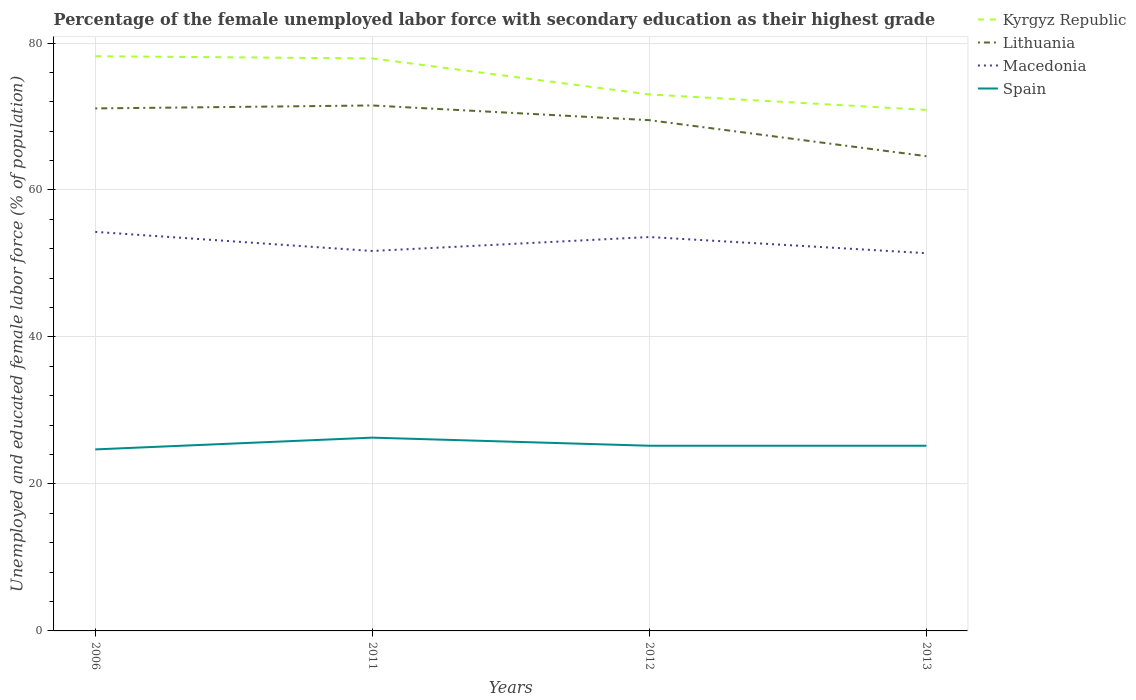Does the line corresponding to Kyrgyz Republic intersect with the line corresponding to Lithuania?
Provide a short and direct response. No. Across all years, what is the maximum percentage of the unemployed female labor force with secondary education in Kyrgyz Republic?
Provide a short and direct response. 70.9. What is the total percentage of the unemployed female labor force with secondary education in Kyrgyz Republic in the graph?
Your answer should be very brief. 4.9. What is the difference between the highest and the second highest percentage of the unemployed female labor force with secondary education in Spain?
Provide a succinct answer. 1.6. Does the graph contain grids?
Your response must be concise. Yes. How many legend labels are there?
Your answer should be compact. 4. How are the legend labels stacked?
Offer a terse response. Vertical. What is the title of the graph?
Ensure brevity in your answer.  Percentage of the female unemployed labor force with secondary education as their highest grade. Does "Zimbabwe" appear as one of the legend labels in the graph?
Your answer should be compact. No. What is the label or title of the Y-axis?
Ensure brevity in your answer.  Unemployed and educated female labor force (% of population). What is the Unemployed and educated female labor force (% of population) in Kyrgyz Republic in 2006?
Make the answer very short. 78.2. What is the Unemployed and educated female labor force (% of population) of Lithuania in 2006?
Your answer should be compact. 71.1. What is the Unemployed and educated female labor force (% of population) of Macedonia in 2006?
Your response must be concise. 54.3. What is the Unemployed and educated female labor force (% of population) of Spain in 2006?
Ensure brevity in your answer.  24.7. What is the Unemployed and educated female labor force (% of population) of Kyrgyz Republic in 2011?
Offer a very short reply. 77.9. What is the Unemployed and educated female labor force (% of population) in Lithuania in 2011?
Offer a terse response. 71.5. What is the Unemployed and educated female labor force (% of population) in Macedonia in 2011?
Keep it short and to the point. 51.7. What is the Unemployed and educated female labor force (% of population) in Spain in 2011?
Make the answer very short. 26.3. What is the Unemployed and educated female labor force (% of population) in Lithuania in 2012?
Ensure brevity in your answer.  69.5. What is the Unemployed and educated female labor force (% of population) of Macedonia in 2012?
Provide a succinct answer. 53.6. What is the Unemployed and educated female labor force (% of population) in Spain in 2012?
Ensure brevity in your answer.  25.2. What is the Unemployed and educated female labor force (% of population) in Kyrgyz Republic in 2013?
Give a very brief answer. 70.9. What is the Unemployed and educated female labor force (% of population) of Lithuania in 2013?
Give a very brief answer. 64.6. What is the Unemployed and educated female labor force (% of population) of Macedonia in 2013?
Ensure brevity in your answer.  51.4. What is the Unemployed and educated female labor force (% of population) of Spain in 2013?
Your answer should be very brief. 25.2. Across all years, what is the maximum Unemployed and educated female labor force (% of population) in Kyrgyz Republic?
Your answer should be compact. 78.2. Across all years, what is the maximum Unemployed and educated female labor force (% of population) in Lithuania?
Give a very brief answer. 71.5. Across all years, what is the maximum Unemployed and educated female labor force (% of population) in Macedonia?
Your response must be concise. 54.3. Across all years, what is the maximum Unemployed and educated female labor force (% of population) of Spain?
Provide a succinct answer. 26.3. Across all years, what is the minimum Unemployed and educated female labor force (% of population) of Kyrgyz Republic?
Ensure brevity in your answer.  70.9. Across all years, what is the minimum Unemployed and educated female labor force (% of population) in Lithuania?
Ensure brevity in your answer.  64.6. Across all years, what is the minimum Unemployed and educated female labor force (% of population) in Macedonia?
Offer a terse response. 51.4. Across all years, what is the minimum Unemployed and educated female labor force (% of population) in Spain?
Your response must be concise. 24.7. What is the total Unemployed and educated female labor force (% of population) of Kyrgyz Republic in the graph?
Keep it short and to the point. 300. What is the total Unemployed and educated female labor force (% of population) of Lithuania in the graph?
Offer a terse response. 276.7. What is the total Unemployed and educated female labor force (% of population) in Macedonia in the graph?
Offer a terse response. 211. What is the total Unemployed and educated female labor force (% of population) of Spain in the graph?
Offer a very short reply. 101.4. What is the difference between the Unemployed and educated female labor force (% of population) in Kyrgyz Republic in 2006 and that in 2011?
Your answer should be compact. 0.3. What is the difference between the Unemployed and educated female labor force (% of population) in Lithuania in 2006 and that in 2011?
Make the answer very short. -0.4. What is the difference between the Unemployed and educated female labor force (% of population) of Macedonia in 2006 and that in 2011?
Give a very brief answer. 2.6. What is the difference between the Unemployed and educated female labor force (% of population) of Spain in 2006 and that in 2011?
Offer a terse response. -1.6. What is the difference between the Unemployed and educated female labor force (% of population) of Macedonia in 2006 and that in 2012?
Your answer should be compact. 0.7. What is the difference between the Unemployed and educated female labor force (% of population) of Kyrgyz Republic in 2006 and that in 2013?
Your response must be concise. 7.3. What is the difference between the Unemployed and educated female labor force (% of population) of Lithuania in 2006 and that in 2013?
Offer a terse response. 6.5. What is the difference between the Unemployed and educated female labor force (% of population) of Macedonia in 2006 and that in 2013?
Give a very brief answer. 2.9. What is the difference between the Unemployed and educated female labor force (% of population) of Macedonia in 2011 and that in 2012?
Your response must be concise. -1.9. What is the difference between the Unemployed and educated female labor force (% of population) in Spain in 2011 and that in 2012?
Make the answer very short. 1.1. What is the difference between the Unemployed and educated female labor force (% of population) in Lithuania in 2011 and that in 2013?
Keep it short and to the point. 6.9. What is the difference between the Unemployed and educated female labor force (% of population) of Lithuania in 2012 and that in 2013?
Make the answer very short. 4.9. What is the difference between the Unemployed and educated female labor force (% of population) in Macedonia in 2012 and that in 2013?
Provide a succinct answer. 2.2. What is the difference between the Unemployed and educated female labor force (% of population) in Spain in 2012 and that in 2013?
Provide a succinct answer. 0. What is the difference between the Unemployed and educated female labor force (% of population) of Kyrgyz Republic in 2006 and the Unemployed and educated female labor force (% of population) of Macedonia in 2011?
Your response must be concise. 26.5. What is the difference between the Unemployed and educated female labor force (% of population) of Kyrgyz Republic in 2006 and the Unemployed and educated female labor force (% of population) of Spain in 2011?
Keep it short and to the point. 51.9. What is the difference between the Unemployed and educated female labor force (% of population) of Lithuania in 2006 and the Unemployed and educated female labor force (% of population) of Spain in 2011?
Keep it short and to the point. 44.8. What is the difference between the Unemployed and educated female labor force (% of population) of Macedonia in 2006 and the Unemployed and educated female labor force (% of population) of Spain in 2011?
Your response must be concise. 28. What is the difference between the Unemployed and educated female labor force (% of population) in Kyrgyz Republic in 2006 and the Unemployed and educated female labor force (% of population) in Lithuania in 2012?
Your answer should be very brief. 8.7. What is the difference between the Unemployed and educated female labor force (% of population) of Kyrgyz Republic in 2006 and the Unemployed and educated female labor force (% of population) of Macedonia in 2012?
Offer a very short reply. 24.6. What is the difference between the Unemployed and educated female labor force (% of population) in Lithuania in 2006 and the Unemployed and educated female labor force (% of population) in Macedonia in 2012?
Ensure brevity in your answer.  17.5. What is the difference between the Unemployed and educated female labor force (% of population) in Lithuania in 2006 and the Unemployed and educated female labor force (% of population) in Spain in 2012?
Your response must be concise. 45.9. What is the difference between the Unemployed and educated female labor force (% of population) in Macedonia in 2006 and the Unemployed and educated female labor force (% of population) in Spain in 2012?
Offer a terse response. 29.1. What is the difference between the Unemployed and educated female labor force (% of population) of Kyrgyz Republic in 2006 and the Unemployed and educated female labor force (% of population) of Lithuania in 2013?
Your answer should be very brief. 13.6. What is the difference between the Unemployed and educated female labor force (% of population) of Kyrgyz Republic in 2006 and the Unemployed and educated female labor force (% of population) of Macedonia in 2013?
Provide a succinct answer. 26.8. What is the difference between the Unemployed and educated female labor force (% of population) of Kyrgyz Republic in 2006 and the Unemployed and educated female labor force (% of population) of Spain in 2013?
Your answer should be very brief. 53. What is the difference between the Unemployed and educated female labor force (% of population) in Lithuania in 2006 and the Unemployed and educated female labor force (% of population) in Macedonia in 2013?
Provide a short and direct response. 19.7. What is the difference between the Unemployed and educated female labor force (% of population) of Lithuania in 2006 and the Unemployed and educated female labor force (% of population) of Spain in 2013?
Ensure brevity in your answer.  45.9. What is the difference between the Unemployed and educated female labor force (% of population) of Macedonia in 2006 and the Unemployed and educated female labor force (% of population) of Spain in 2013?
Keep it short and to the point. 29.1. What is the difference between the Unemployed and educated female labor force (% of population) of Kyrgyz Republic in 2011 and the Unemployed and educated female labor force (% of population) of Macedonia in 2012?
Your answer should be compact. 24.3. What is the difference between the Unemployed and educated female labor force (% of population) in Kyrgyz Republic in 2011 and the Unemployed and educated female labor force (% of population) in Spain in 2012?
Your answer should be compact. 52.7. What is the difference between the Unemployed and educated female labor force (% of population) in Lithuania in 2011 and the Unemployed and educated female labor force (% of population) in Macedonia in 2012?
Your response must be concise. 17.9. What is the difference between the Unemployed and educated female labor force (% of population) of Lithuania in 2011 and the Unemployed and educated female labor force (% of population) of Spain in 2012?
Make the answer very short. 46.3. What is the difference between the Unemployed and educated female labor force (% of population) in Macedonia in 2011 and the Unemployed and educated female labor force (% of population) in Spain in 2012?
Offer a very short reply. 26.5. What is the difference between the Unemployed and educated female labor force (% of population) of Kyrgyz Republic in 2011 and the Unemployed and educated female labor force (% of population) of Spain in 2013?
Provide a succinct answer. 52.7. What is the difference between the Unemployed and educated female labor force (% of population) in Lithuania in 2011 and the Unemployed and educated female labor force (% of population) in Macedonia in 2013?
Make the answer very short. 20.1. What is the difference between the Unemployed and educated female labor force (% of population) of Lithuania in 2011 and the Unemployed and educated female labor force (% of population) of Spain in 2013?
Provide a succinct answer. 46.3. What is the difference between the Unemployed and educated female labor force (% of population) of Macedonia in 2011 and the Unemployed and educated female labor force (% of population) of Spain in 2013?
Offer a very short reply. 26.5. What is the difference between the Unemployed and educated female labor force (% of population) in Kyrgyz Republic in 2012 and the Unemployed and educated female labor force (% of population) in Macedonia in 2013?
Offer a terse response. 21.6. What is the difference between the Unemployed and educated female labor force (% of population) in Kyrgyz Republic in 2012 and the Unemployed and educated female labor force (% of population) in Spain in 2013?
Ensure brevity in your answer.  47.8. What is the difference between the Unemployed and educated female labor force (% of population) of Lithuania in 2012 and the Unemployed and educated female labor force (% of population) of Macedonia in 2013?
Offer a very short reply. 18.1. What is the difference between the Unemployed and educated female labor force (% of population) of Lithuania in 2012 and the Unemployed and educated female labor force (% of population) of Spain in 2013?
Provide a short and direct response. 44.3. What is the difference between the Unemployed and educated female labor force (% of population) in Macedonia in 2012 and the Unemployed and educated female labor force (% of population) in Spain in 2013?
Ensure brevity in your answer.  28.4. What is the average Unemployed and educated female labor force (% of population) of Kyrgyz Republic per year?
Ensure brevity in your answer.  75. What is the average Unemployed and educated female labor force (% of population) of Lithuania per year?
Your answer should be compact. 69.17. What is the average Unemployed and educated female labor force (% of population) of Macedonia per year?
Give a very brief answer. 52.75. What is the average Unemployed and educated female labor force (% of population) in Spain per year?
Provide a short and direct response. 25.35. In the year 2006, what is the difference between the Unemployed and educated female labor force (% of population) of Kyrgyz Republic and Unemployed and educated female labor force (% of population) of Lithuania?
Keep it short and to the point. 7.1. In the year 2006, what is the difference between the Unemployed and educated female labor force (% of population) of Kyrgyz Republic and Unemployed and educated female labor force (% of population) of Macedonia?
Your answer should be compact. 23.9. In the year 2006, what is the difference between the Unemployed and educated female labor force (% of population) of Kyrgyz Republic and Unemployed and educated female labor force (% of population) of Spain?
Your answer should be compact. 53.5. In the year 2006, what is the difference between the Unemployed and educated female labor force (% of population) of Lithuania and Unemployed and educated female labor force (% of population) of Macedonia?
Provide a succinct answer. 16.8. In the year 2006, what is the difference between the Unemployed and educated female labor force (% of population) of Lithuania and Unemployed and educated female labor force (% of population) of Spain?
Give a very brief answer. 46.4. In the year 2006, what is the difference between the Unemployed and educated female labor force (% of population) in Macedonia and Unemployed and educated female labor force (% of population) in Spain?
Provide a short and direct response. 29.6. In the year 2011, what is the difference between the Unemployed and educated female labor force (% of population) of Kyrgyz Republic and Unemployed and educated female labor force (% of population) of Macedonia?
Ensure brevity in your answer.  26.2. In the year 2011, what is the difference between the Unemployed and educated female labor force (% of population) of Kyrgyz Republic and Unemployed and educated female labor force (% of population) of Spain?
Your answer should be compact. 51.6. In the year 2011, what is the difference between the Unemployed and educated female labor force (% of population) of Lithuania and Unemployed and educated female labor force (% of population) of Macedonia?
Provide a succinct answer. 19.8. In the year 2011, what is the difference between the Unemployed and educated female labor force (% of population) in Lithuania and Unemployed and educated female labor force (% of population) in Spain?
Keep it short and to the point. 45.2. In the year 2011, what is the difference between the Unemployed and educated female labor force (% of population) in Macedonia and Unemployed and educated female labor force (% of population) in Spain?
Keep it short and to the point. 25.4. In the year 2012, what is the difference between the Unemployed and educated female labor force (% of population) of Kyrgyz Republic and Unemployed and educated female labor force (% of population) of Spain?
Provide a succinct answer. 47.8. In the year 2012, what is the difference between the Unemployed and educated female labor force (% of population) in Lithuania and Unemployed and educated female labor force (% of population) in Macedonia?
Make the answer very short. 15.9. In the year 2012, what is the difference between the Unemployed and educated female labor force (% of population) of Lithuania and Unemployed and educated female labor force (% of population) of Spain?
Make the answer very short. 44.3. In the year 2012, what is the difference between the Unemployed and educated female labor force (% of population) in Macedonia and Unemployed and educated female labor force (% of population) in Spain?
Provide a short and direct response. 28.4. In the year 2013, what is the difference between the Unemployed and educated female labor force (% of population) in Kyrgyz Republic and Unemployed and educated female labor force (% of population) in Lithuania?
Keep it short and to the point. 6.3. In the year 2013, what is the difference between the Unemployed and educated female labor force (% of population) in Kyrgyz Republic and Unemployed and educated female labor force (% of population) in Spain?
Your answer should be very brief. 45.7. In the year 2013, what is the difference between the Unemployed and educated female labor force (% of population) in Lithuania and Unemployed and educated female labor force (% of population) in Spain?
Your response must be concise. 39.4. In the year 2013, what is the difference between the Unemployed and educated female labor force (% of population) in Macedonia and Unemployed and educated female labor force (% of population) in Spain?
Ensure brevity in your answer.  26.2. What is the ratio of the Unemployed and educated female labor force (% of population) in Kyrgyz Republic in 2006 to that in 2011?
Offer a terse response. 1. What is the ratio of the Unemployed and educated female labor force (% of population) of Macedonia in 2006 to that in 2011?
Keep it short and to the point. 1.05. What is the ratio of the Unemployed and educated female labor force (% of population) in Spain in 2006 to that in 2011?
Make the answer very short. 0.94. What is the ratio of the Unemployed and educated female labor force (% of population) in Kyrgyz Republic in 2006 to that in 2012?
Offer a very short reply. 1.07. What is the ratio of the Unemployed and educated female labor force (% of population) in Macedonia in 2006 to that in 2012?
Provide a short and direct response. 1.01. What is the ratio of the Unemployed and educated female labor force (% of population) in Spain in 2006 to that in 2012?
Ensure brevity in your answer.  0.98. What is the ratio of the Unemployed and educated female labor force (% of population) in Kyrgyz Republic in 2006 to that in 2013?
Ensure brevity in your answer.  1.1. What is the ratio of the Unemployed and educated female labor force (% of population) of Lithuania in 2006 to that in 2013?
Provide a succinct answer. 1.1. What is the ratio of the Unemployed and educated female labor force (% of population) of Macedonia in 2006 to that in 2013?
Ensure brevity in your answer.  1.06. What is the ratio of the Unemployed and educated female labor force (% of population) of Spain in 2006 to that in 2013?
Provide a short and direct response. 0.98. What is the ratio of the Unemployed and educated female labor force (% of population) in Kyrgyz Republic in 2011 to that in 2012?
Provide a short and direct response. 1.07. What is the ratio of the Unemployed and educated female labor force (% of population) in Lithuania in 2011 to that in 2012?
Your answer should be compact. 1.03. What is the ratio of the Unemployed and educated female labor force (% of population) in Macedonia in 2011 to that in 2012?
Make the answer very short. 0.96. What is the ratio of the Unemployed and educated female labor force (% of population) of Spain in 2011 to that in 2012?
Keep it short and to the point. 1.04. What is the ratio of the Unemployed and educated female labor force (% of population) in Kyrgyz Republic in 2011 to that in 2013?
Give a very brief answer. 1.1. What is the ratio of the Unemployed and educated female labor force (% of population) in Lithuania in 2011 to that in 2013?
Your answer should be compact. 1.11. What is the ratio of the Unemployed and educated female labor force (% of population) of Spain in 2011 to that in 2013?
Make the answer very short. 1.04. What is the ratio of the Unemployed and educated female labor force (% of population) of Kyrgyz Republic in 2012 to that in 2013?
Offer a terse response. 1.03. What is the ratio of the Unemployed and educated female labor force (% of population) in Lithuania in 2012 to that in 2013?
Provide a succinct answer. 1.08. What is the ratio of the Unemployed and educated female labor force (% of population) of Macedonia in 2012 to that in 2013?
Offer a very short reply. 1.04. What is the difference between the highest and the second highest Unemployed and educated female labor force (% of population) in Kyrgyz Republic?
Your response must be concise. 0.3. What is the difference between the highest and the second highest Unemployed and educated female labor force (% of population) in Lithuania?
Give a very brief answer. 0.4. What is the difference between the highest and the lowest Unemployed and educated female labor force (% of population) of Lithuania?
Ensure brevity in your answer.  6.9. 